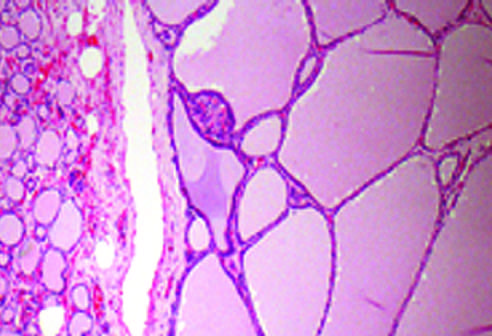do the hyperplastic follicles contain abundant pink colloid within their lumina?
Answer the question using a single word or phrase. Yes 